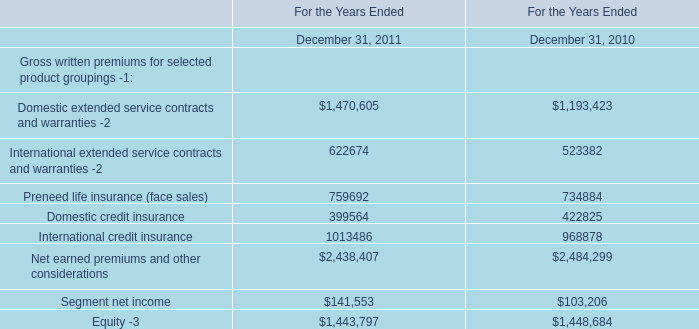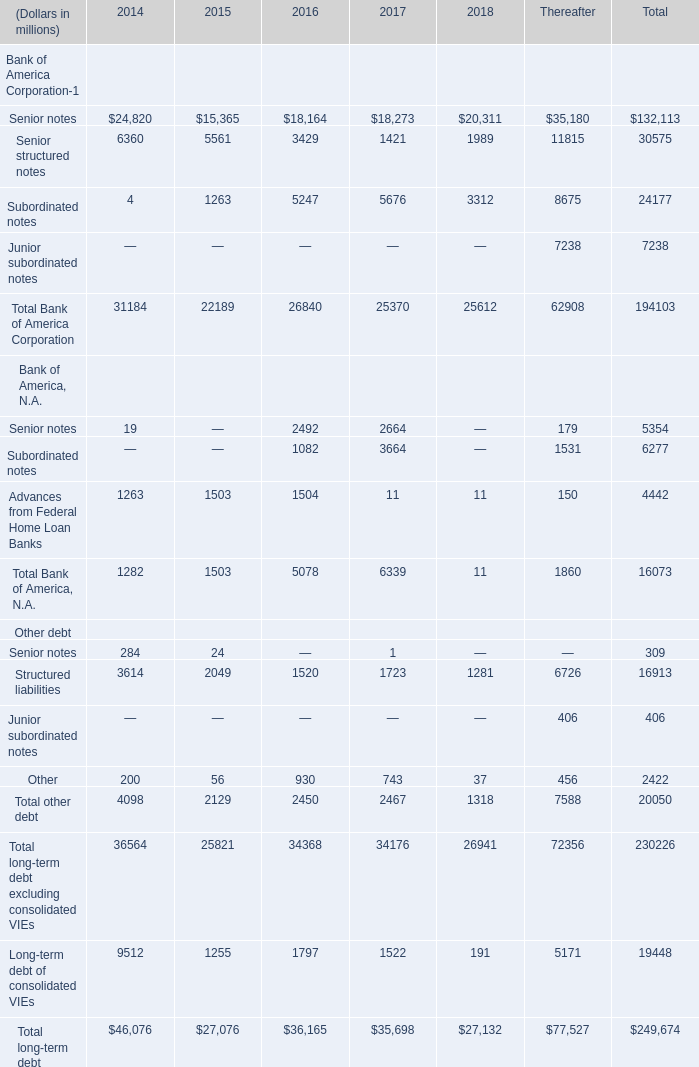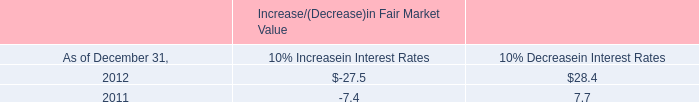What is the proportion of Total Bank of America Corporation to the total in 2014? 
Computations: (31184 / 46076)
Answer: 0.67679. 